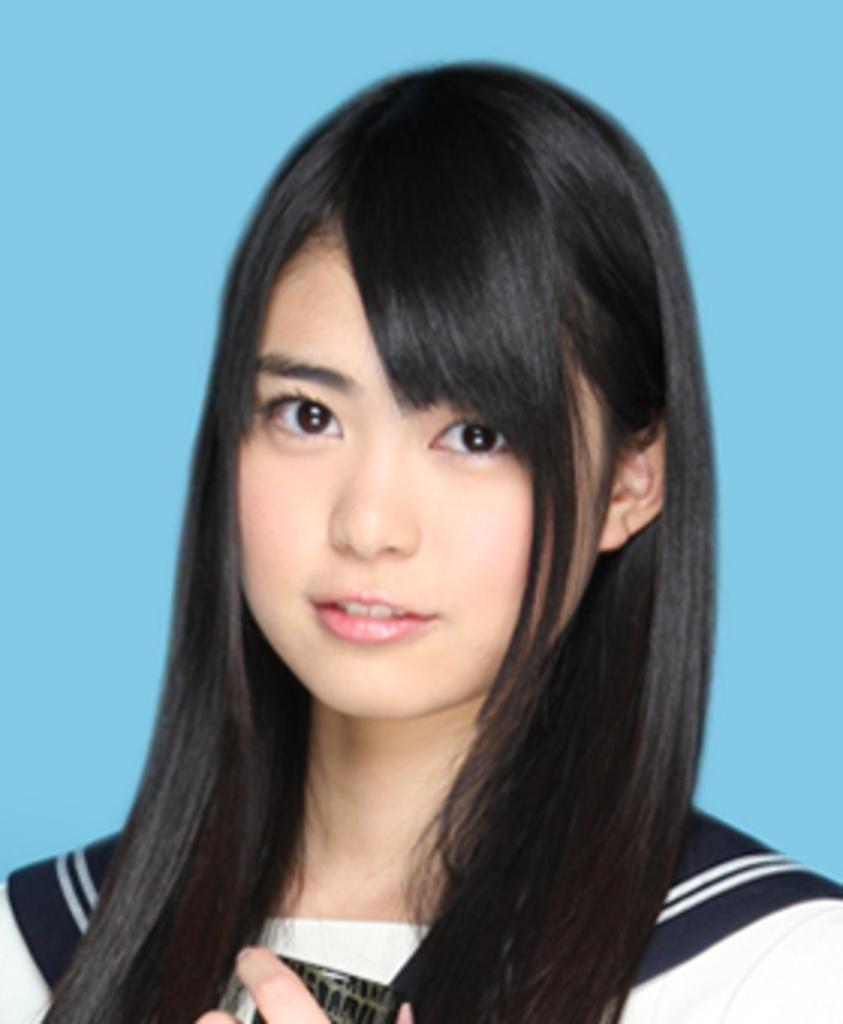Could you give a brief overview of what you see in this image? In this image I can see a woman with blue color background. This image is taken may be in a room. 